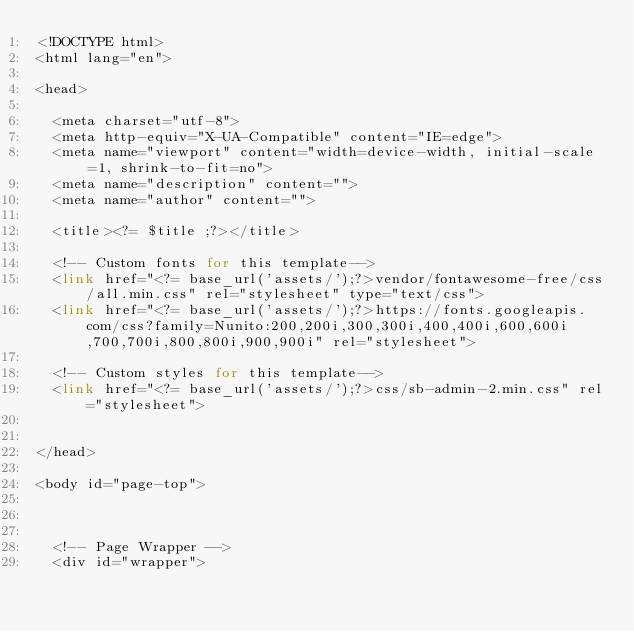Convert code to text. <code><loc_0><loc_0><loc_500><loc_500><_PHP_><!DOCTYPE html>
<html lang="en">

<head>

  <meta charset="utf-8">
  <meta http-equiv="X-UA-Compatible" content="IE=edge">
  <meta name="viewport" content="width=device-width, initial-scale=1, shrink-to-fit=no">
  <meta name="description" content="">
  <meta name="author" content="">

  <title><?= $title ;?></title>

  <!-- Custom fonts for this template-->
  <link href="<?= base_url('assets/');?>vendor/fontawesome-free/css/all.min.css" rel="stylesheet" type="text/css">
  <link href="<?= base_url('assets/');?>https://fonts.googleapis.com/css?family=Nunito:200,200i,300,300i,400,400i,600,600i,700,700i,800,800i,900,900i" rel="stylesheet">

  <!-- Custom styles for this template-->
  <link href="<?= base_url('assets/');?>css/sb-admin-2.min.css" rel="stylesheet">
  

</head>

<body id="page-top">

  

  <!-- Page Wrapper -->
  <div id="wrapper"></code> 